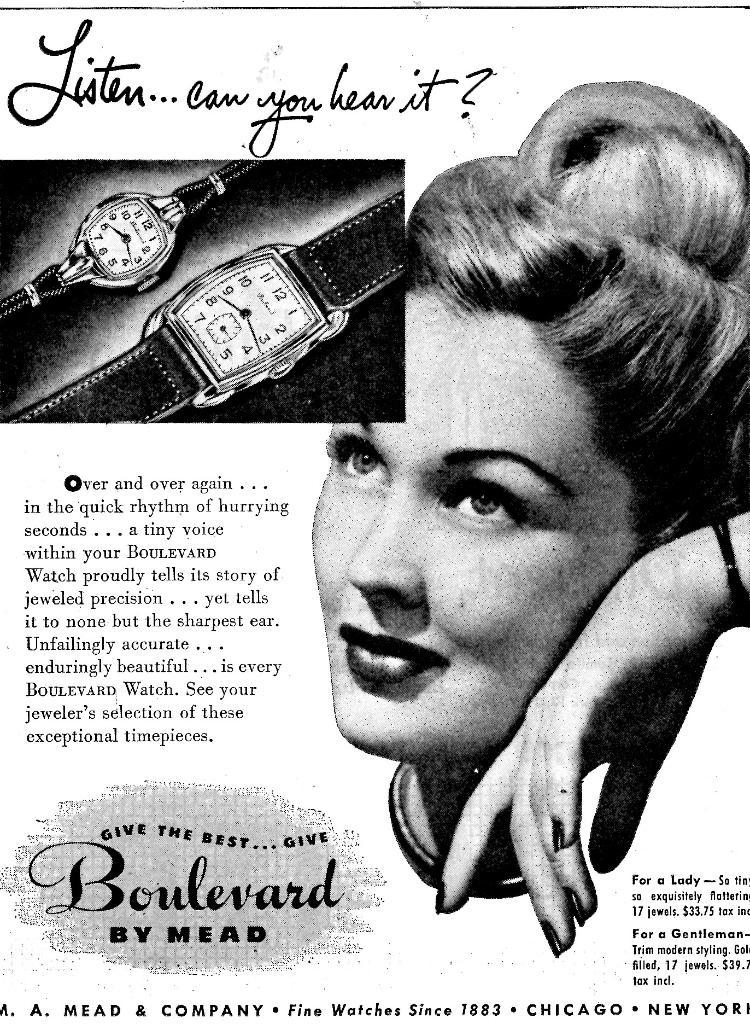<image>
Relay a brief, clear account of the picture shown. An advertisement for Boulevard watches by Mead has a woman on it. 